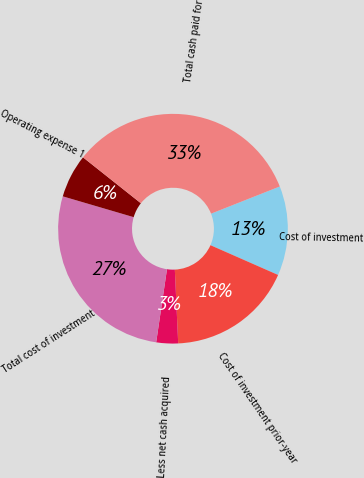Convert chart. <chart><loc_0><loc_0><loc_500><loc_500><pie_chart><fcel>Cost of investment<fcel>Cost of investment prior-year<fcel>Less net cash acquired<fcel>Total cost of investment<fcel>Operating expense 1<fcel>Total cash paid for<nl><fcel>12.59%<fcel>17.68%<fcel>3.06%<fcel>27.21%<fcel>6.13%<fcel>33.33%<nl></chart> 